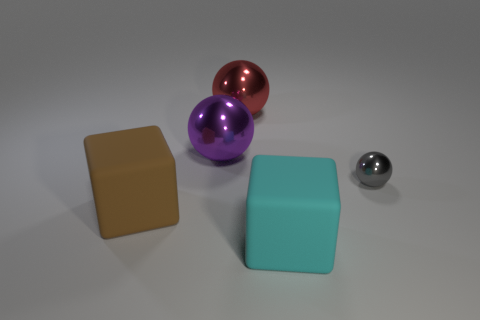Is the gray object made of the same material as the large purple object behind the cyan object?
Provide a succinct answer. Yes. Is the number of large brown things greater than the number of large red cylinders?
Your response must be concise. Yes. How many cubes are either small objects or rubber objects?
Provide a short and direct response. 2. The small metal object has what color?
Your answer should be compact. Gray. Is the size of the matte object right of the large brown block the same as the shiny ball that is on the right side of the big red metal thing?
Provide a succinct answer. No. Are there fewer purple spheres than cubes?
Make the answer very short. Yes. There is a red metallic thing; how many red objects are right of it?
Ensure brevity in your answer.  0. What is the material of the large cyan object?
Provide a succinct answer. Rubber. Are there fewer brown rubber objects that are on the left side of the gray shiny sphere than big green rubber objects?
Offer a terse response. No. What color is the large rubber thing to the left of the red metal sphere?
Your answer should be very brief. Brown. 